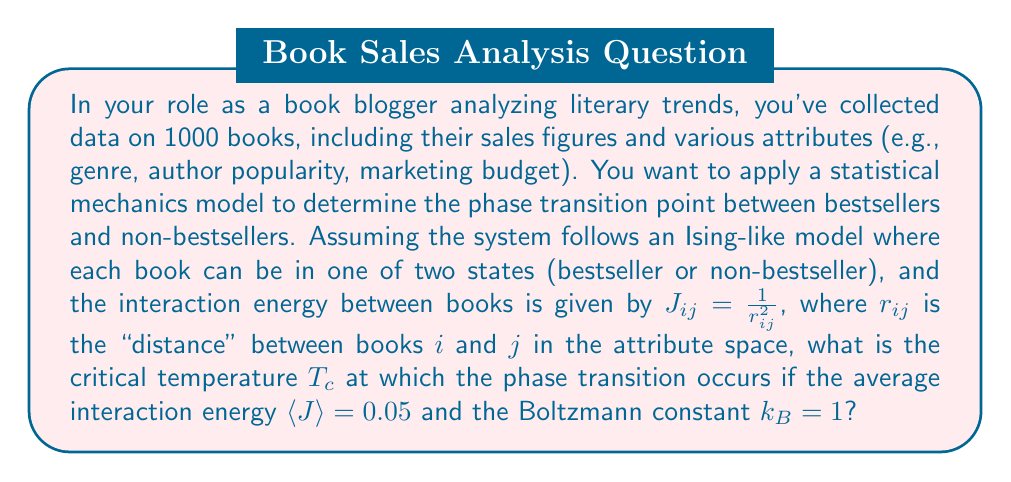Show me your answer to this math problem. To solve this problem, we'll use concepts from statistical mechanics, particularly the Ising model and mean-field theory. Here's a step-by-step approach:

1) In the Ising model, the critical temperature $T_c$ is related to the interaction energy $J$ by the equation:

   $$T_c = \frac{2J}{k_B \ln(1+\sqrt{2})}$$

2) In our case, we have an average interaction energy $\langle J \rangle$ instead of a uniform $J$. We can use this average in place of $J$ in the mean-field approximation.

3) We're given that $\langle J \rangle = 0.05$ and $k_B = 1$.

4) Substituting these values into the equation:

   $$T_c = \frac{2(0.05)}{1 \cdot \ln(1+\sqrt{2})}$$

5) Simplify:
   $$T_c = \frac{0.1}{\ln(1+\sqrt{2})}$$

6) Calculate $\ln(1+\sqrt{2})$:
   $$\ln(1+\sqrt{2}) \approx 0.8814$$

7) Finally, divide:
   $$T_c = \frac{0.1}{0.8814} \approx 0.1134$$

This critical temperature represents the point at which the system transitions from a disordered state (where bestseller status is randomly distributed) to an ordered state (where bestseller status shows clear patterns or clustering).
Answer: $T_c \approx 0.1134$ 